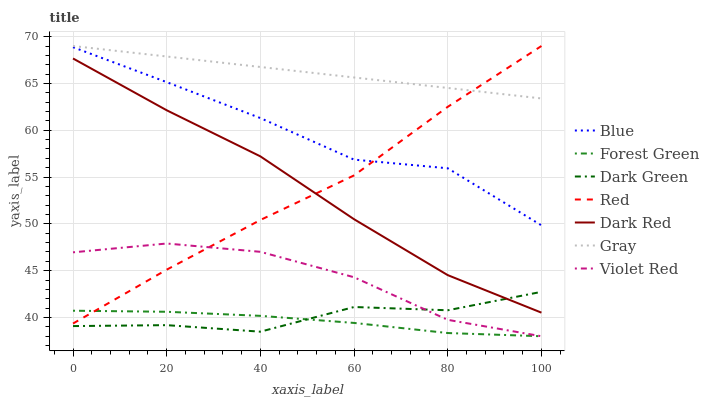Does Forest Green have the minimum area under the curve?
Answer yes or no. Yes. Does Gray have the maximum area under the curve?
Answer yes or no. Yes. Does Violet Red have the minimum area under the curve?
Answer yes or no. No. Does Violet Red have the maximum area under the curve?
Answer yes or no. No. Is Gray the smoothest?
Answer yes or no. Yes. Is Dark Green the roughest?
Answer yes or no. Yes. Is Violet Red the smoothest?
Answer yes or no. No. Is Violet Red the roughest?
Answer yes or no. No. Does Gray have the lowest value?
Answer yes or no. No. Does Violet Red have the highest value?
Answer yes or no. No. Is Forest Green less than Dark Red?
Answer yes or no. Yes. Is Dark Red greater than Violet Red?
Answer yes or no. Yes. Does Forest Green intersect Dark Red?
Answer yes or no. No. 